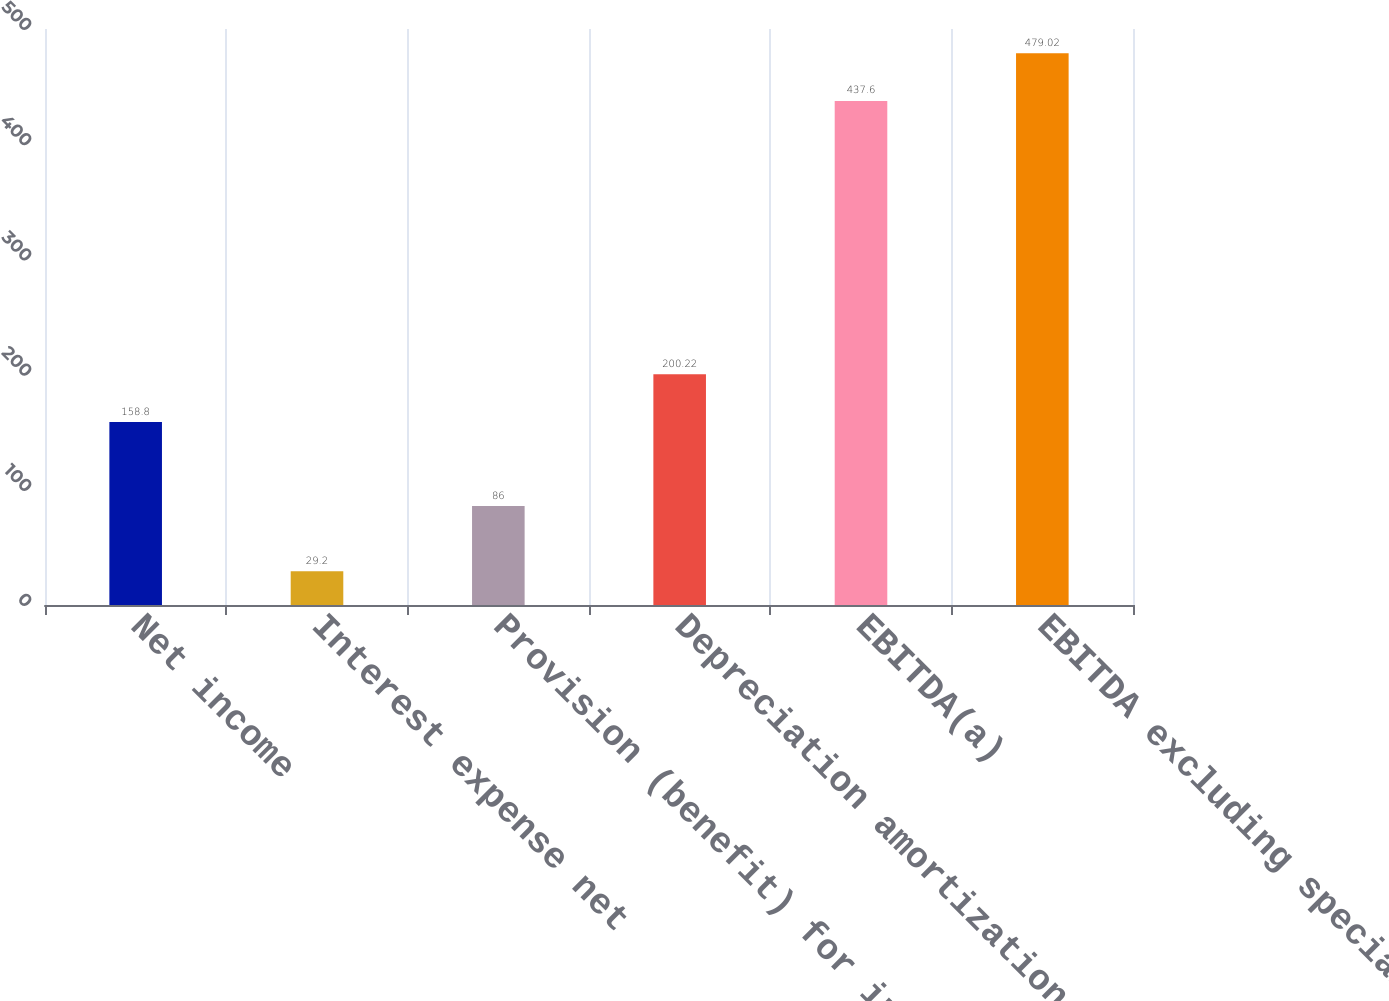Convert chart. <chart><loc_0><loc_0><loc_500><loc_500><bar_chart><fcel>Net income<fcel>Interest expense net<fcel>Provision (benefit) for income<fcel>Depreciation amortization and<fcel>EBITDA(a)<fcel>EBITDA excluding special<nl><fcel>158.8<fcel>29.2<fcel>86<fcel>200.22<fcel>437.6<fcel>479.02<nl></chart> 